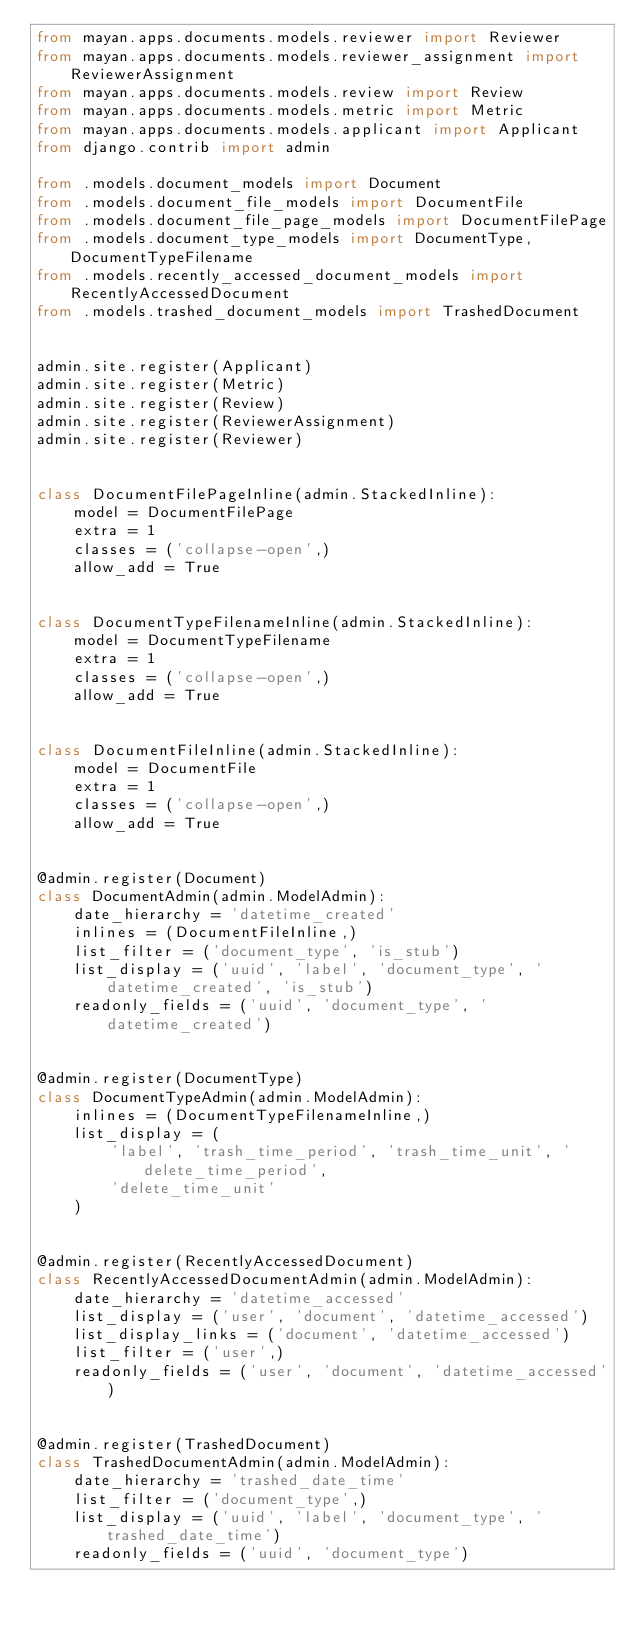Convert code to text. <code><loc_0><loc_0><loc_500><loc_500><_Python_>from mayan.apps.documents.models.reviewer import Reviewer
from mayan.apps.documents.models.reviewer_assignment import ReviewerAssignment
from mayan.apps.documents.models.review import Review
from mayan.apps.documents.models.metric import Metric
from mayan.apps.documents.models.applicant import Applicant
from django.contrib import admin

from .models.document_models import Document
from .models.document_file_models import DocumentFile
from .models.document_file_page_models import DocumentFilePage
from .models.document_type_models import DocumentType, DocumentTypeFilename
from .models.recently_accessed_document_models import RecentlyAccessedDocument
from .models.trashed_document_models import TrashedDocument


admin.site.register(Applicant)
admin.site.register(Metric)
admin.site.register(Review)
admin.site.register(ReviewerAssignment)
admin.site.register(Reviewer)


class DocumentFilePageInline(admin.StackedInline):
    model = DocumentFilePage
    extra = 1
    classes = ('collapse-open',)
    allow_add = True


class DocumentTypeFilenameInline(admin.StackedInline):
    model = DocumentTypeFilename
    extra = 1
    classes = ('collapse-open',)
    allow_add = True


class DocumentFileInline(admin.StackedInline):
    model = DocumentFile
    extra = 1
    classes = ('collapse-open',)
    allow_add = True


@admin.register(Document)
class DocumentAdmin(admin.ModelAdmin):
    date_hierarchy = 'datetime_created'
    inlines = (DocumentFileInline,)
    list_filter = ('document_type', 'is_stub')
    list_display = ('uuid', 'label', 'document_type', 'datetime_created', 'is_stub')
    readonly_fields = ('uuid', 'document_type', 'datetime_created')


@admin.register(DocumentType)
class DocumentTypeAdmin(admin.ModelAdmin):
    inlines = (DocumentTypeFilenameInline,)
    list_display = (
        'label', 'trash_time_period', 'trash_time_unit', 'delete_time_period',
        'delete_time_unit'
    )


@admin.register(RecentlyAccessedDocument)
class RecentlyAccessedDocumentAdmin(admin.ModelAdmin):
    date_hierarchy = 'datetime_accessed'
    list_display = ('user', 'document', 'datetime_accessed')
    list_display_links = ('document', 'datetime_accessed')
    list_filter = ('user',)
    readonly_fields = ('user', 'document', 'datetime_accessed')


@admin.register(TrashedDocument)
class TrashedDocumentAdmin(admin.ModelAdmin):
    date_hierarchy = 'trashed_date_time'
    list_filter = ('document_type',)
    list_display = ('uuid', 'label', 'document_type', 'trashed_date_time')
    readonly_fields = ('uuid', 'document_type')
</code> 